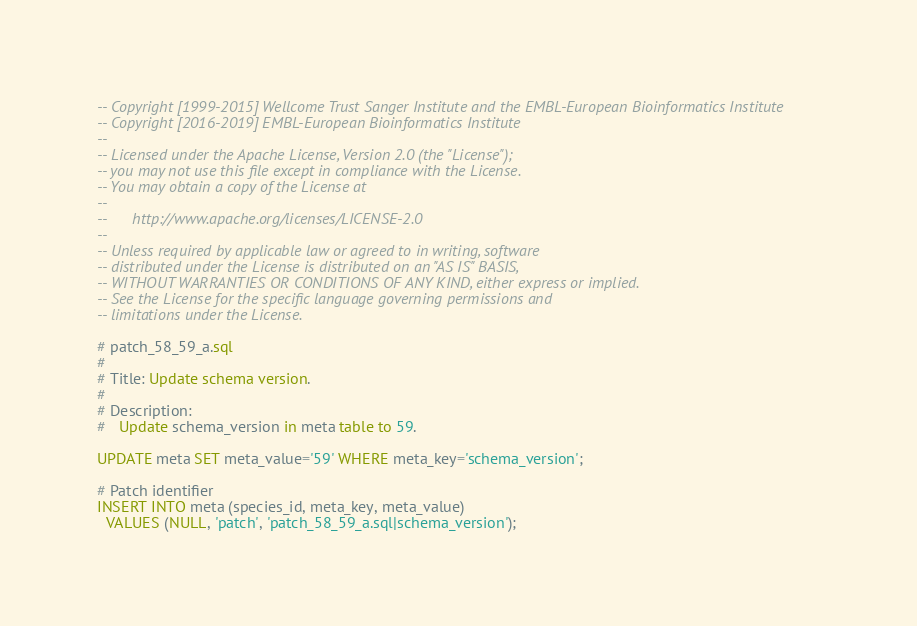Convert code to text. <code><loc_0><loc_0><loc_500><loc_500><_SQL_>-- Copyright [1999-2015] Wellcome Trust Sanger Institute and the EMBL-European Bioinformatics Institute
-- Copyright [2016-2019] EMBL-European Bioinformatics Institute
-- 
-- Licensed under the Apache License, Version 2.0 (the "License");
-- you may not use this file except in compliance with the License.
-- You may obtain a copy of the License at
-- 
--      http://www.apache.org/licenses/LICENSE-2.0
-- 
-- Unless required by applicable law or agreed to in writing, software
-- distributed under the License is distributed on an "AS IS" BASIS,
-- WITHOUT WARRANTIES OR CONDITIONS OF ANY KIND, either express or implied.
-- See the License for the specific language governing permissions and
-- limitations under the License.

# patch_58_59_a.sql
#
# Title: Update schema version.
#
# Description:
#   Update schema_version in meta table to 59.

UPDATE meta SET meta_value='59' WHERE meta_key='schema_version';

# Patch identifier
INSERT INTO meta (species_id, meta_key, meta_value)
  VALUES (NULL, 'patch', 'patch_58_59_a.sql|schema_version');
</code> 